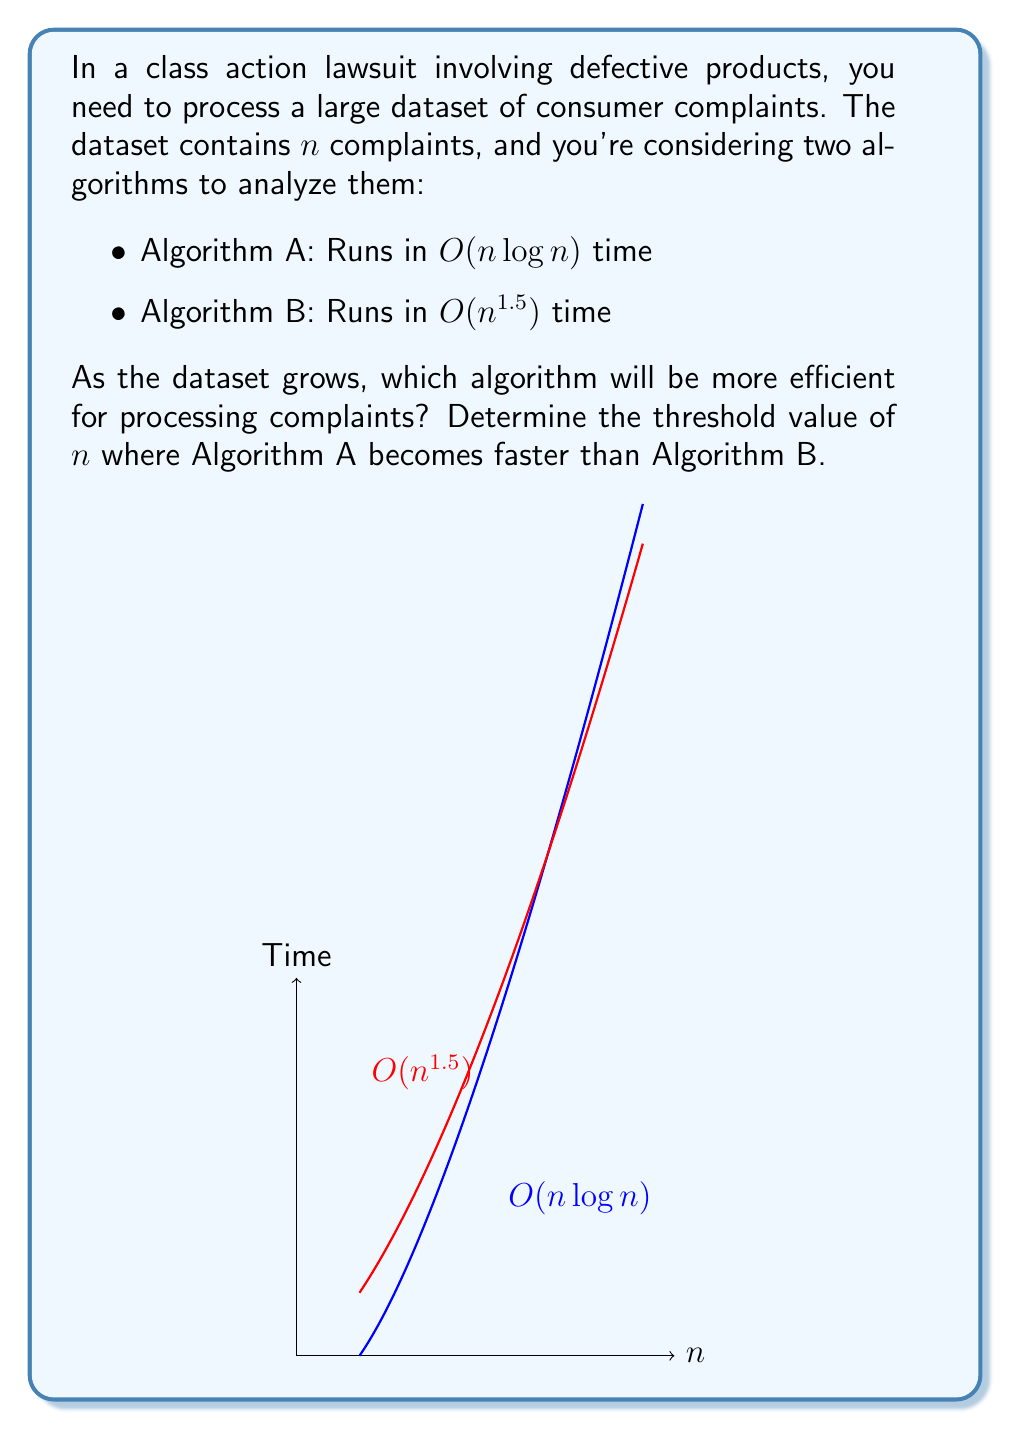Provide a solution to this math problem. To find the threshold where Algorithm A becomes faster than Algorithm B, we need to solve the equation:

$$n \log n = n^{1.5}$$

Let's approach this step-by-step:

1) First, divide both sides by $n$:
   $$\log n = n^{0.5}$$

2) Now, square both sides:
   $$(\log n)^2 = n$$

3) This equation cannot be solved algebraically. We need to use numerical methods or graph intersection to find the solution.

4) Using a graphing calculator or computer algebra system, we can find that the intersection occurs at approximately $n \approx 43.55$.

5) Since $n$ must be a whole number in this context (number of complaints), we round up to the nearest integer.

6) Therefore, for $n \geq 44$, Algorithm A will be faster than Algorithm B.

7) To verify:
   For $n = 43$:
   Algorithm A: $43 \log 43 \approx 157.53$
   Algorithm B: $43^{1.5} \approx 157.41$
   
   For $n = 44$:
   Algorithm A: $44 \log 44 \approx 163.41$
   Algorithm B: $44^{1.5} \approx 163.64$

This confirms that Algorithm A becomes faster at $n = 44$.
Answer: $n \geq 44$ 